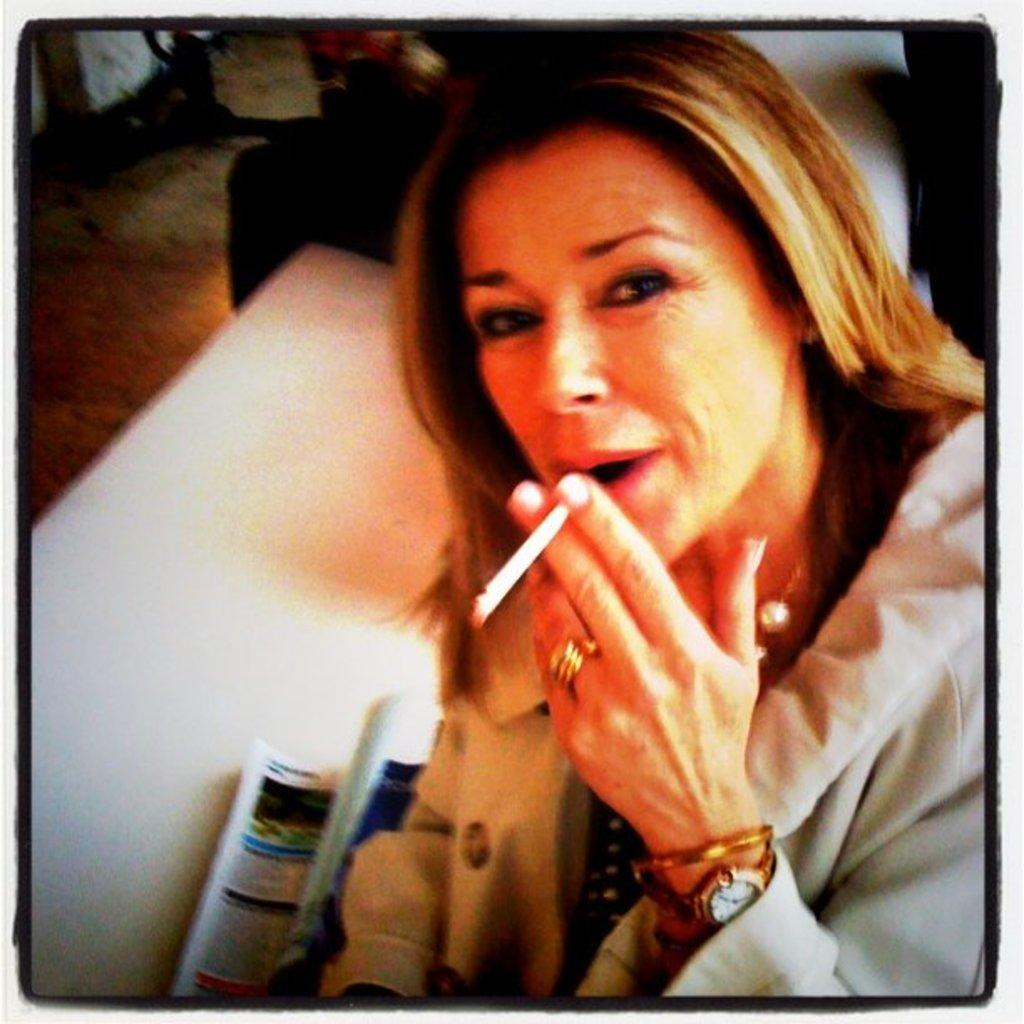What is the person in the image holding? The person is holding a cigarette in the image. What else can be seen in the image besides the person? There is a book in the image. Where is the book placed? The book is on a white surface. Can you describe the background of the image? The background of the image is blurred. What type of riddle can be found in the wilderness in the image? There is no riddle or wilderness present in the image; it features a person holding a cigarette and a book on a white surface with a blurred background. 